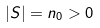Convert formula to latex. <formula><loc_0><loc_0><loc_500><loc_500>| S | = n _ { 0 } > 0</formula> 